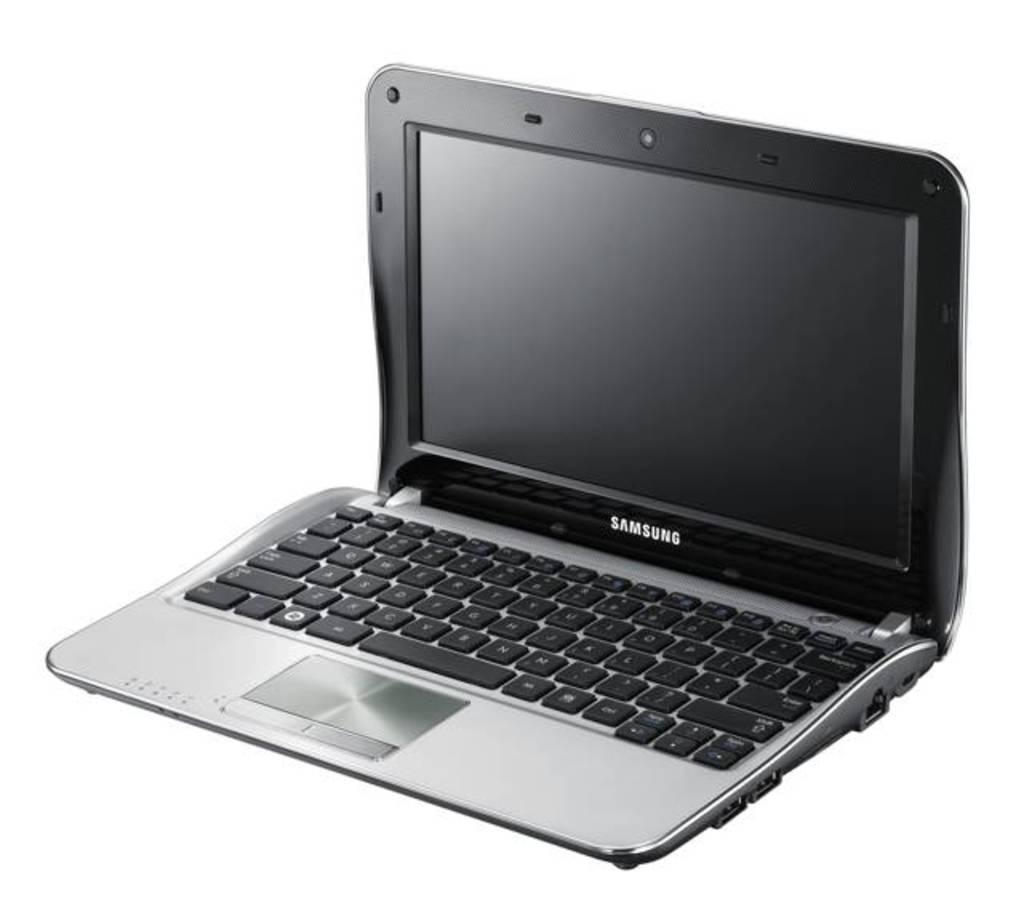<image>
Describe the image concisely. A black laptop made by the company Samsung. 